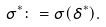Convert formula to latex. <formula><loc_0><loc_0><loc_500><loc_500>\sigma ^ { * } \colon = \sigma ( \delta ^ { * } ) .</formula> 